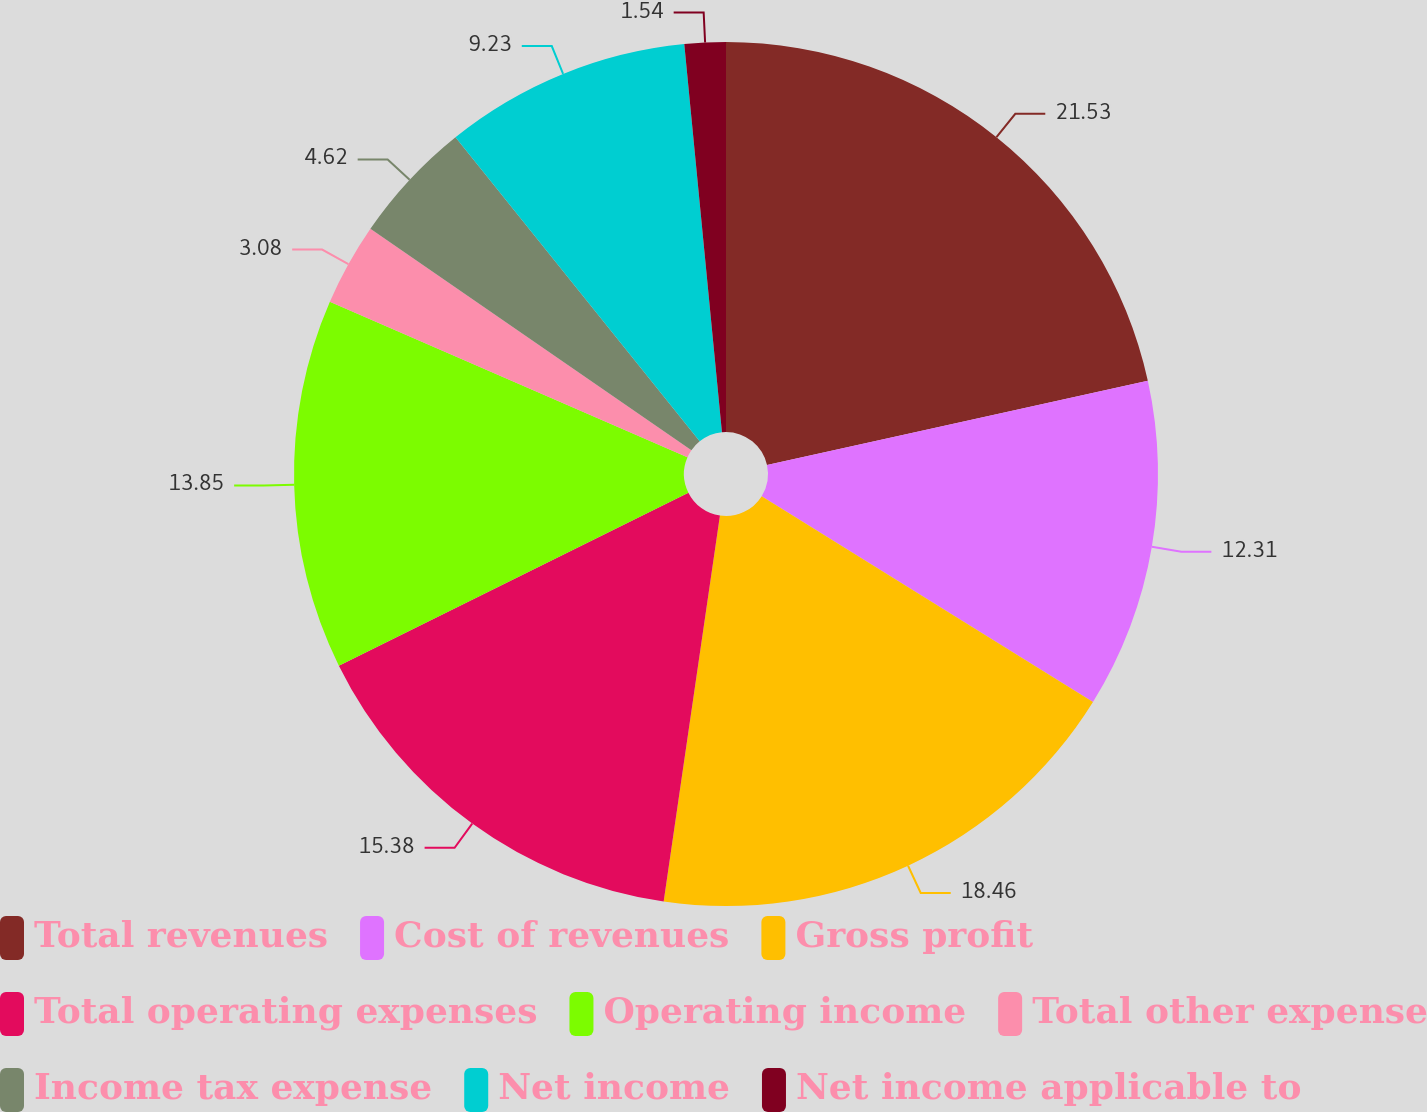Convert chart. <chart><loc_0><loc_0><loc_500><loc_500><pie_chart><fcel>Total revenues<fcel>Cost of revenues<fcel>Gross profit<fcel>Total operating expenses<fcel>Operating income<fcel>Total other expense<fcel>Income tax expense<fcel>Net income<fcel>Net income applicable to<nl><fcel>21.54%<fcel>12.31%<fcel>18.46%<fcel>15.38%<fcel>13.85%<fcel>3.08%<fcel>4.62%<fcel>9.23%<fcel>1.54%<nl></chart> 